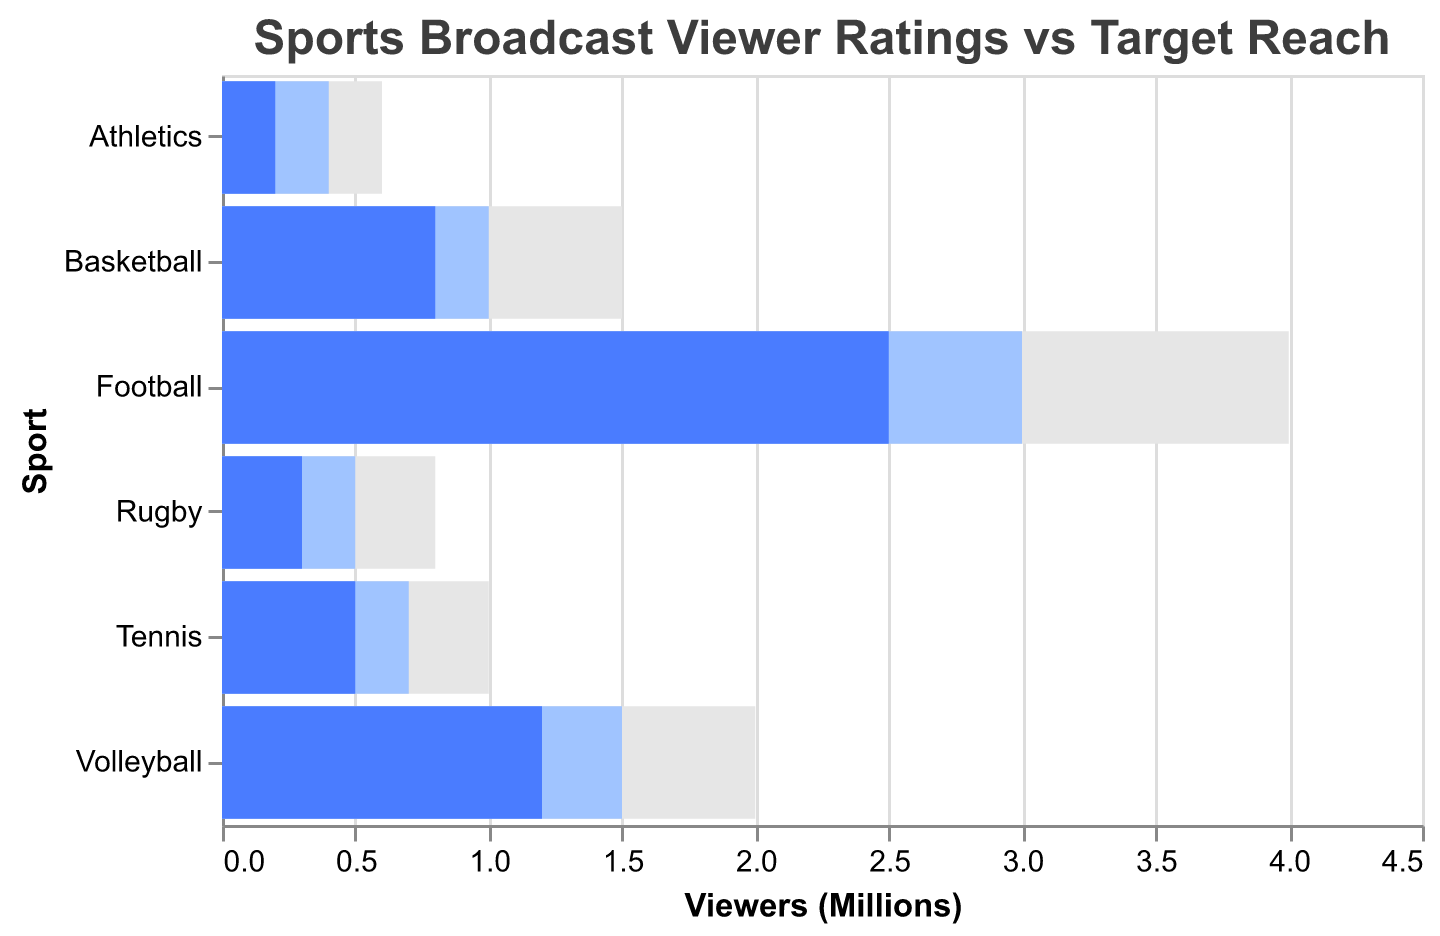What's the title of the figure? The title is usually displayed at the top of a chart in a larger font. It helps to understand the context of the chart. Here, the title is clearly mentioned at the top.
Answer: Sports Broadcast Viewer Ratings vs Target Reach Which sport has the highest maximum potential viewers? To determine this, compare the values in the "Maximum Potential (Millions)" column and identify the highest number. In this case, Football has the highest value of 4.0 million.
Answer: Football How many sports are being compared in the chart? Count the number of unique entries under the "Sport" category. There are six sports listed: Football, Volleyball, Basketball, Tennis, Rugby, and Athletics.
Answer: 6 Which sport came closest to its target reach in terms of viewers? To find this, calculate the difference between "Actual Viewers (Millions)" and "Target Reach (Millions)" for each sport. The sport with the smallest difference is the closest to its target. Football has 2.5 compared to a target of 3.0, so the difference is 0.5.
Answer: Football Which sport had the lowest number of actual viewers? Compare the values under "Actual Viewers (Millions)" and identify the lowest one. Athletics has the lowest number of actual viewers at 0.2 million.
Answer: Athletics How much higher was the maximum potential reach for volleyball compared to its target reach? Subtract the target reach from the maximum potential for Volleyball. Maximum potential is 2.0 million, and target reach is 1.5 million. So, 2.0 - 1.5 = 0.5 million.
Answer: 0.5 million How many sports had actual viewers less than 1 million? Count the number of sports where the "Actual Viewers (Millions)" column is less than 1.0. This includes Basketball, Tennis, Rugby, and Athletics.
Answer: 4 What is the combined total of the target reach for all sports? Add up all the values in the "Target Reach (Millions)" column: 3.0 + 1.5 + 1.0 + 0.7 + 0.5 + 0.4 = 7.1 million.
Answer: 7.1 million For which sport is the gap between actual viewers and maximum potential the largest? For each sport, subtract "Actual Viewers (Millions)" from "Maximum Potential (Millions)" and identify the largest difference. For Football, it is 4.0 - 2.5 = 1.5 million; Volleyball, 2.0 - 1.2 = 0.8 million; Basketball, 1.5 - 0.8 = 0.7 million; Tennis, 1.0 - 0.5 = 0.5 million; Rugby, 0.8 - 0.3 = 0.5 million; and Athletics, 0.6 - 0.2 = 0.4 million. The largest gap is for Football at 1.5 million.
Answer: Football 